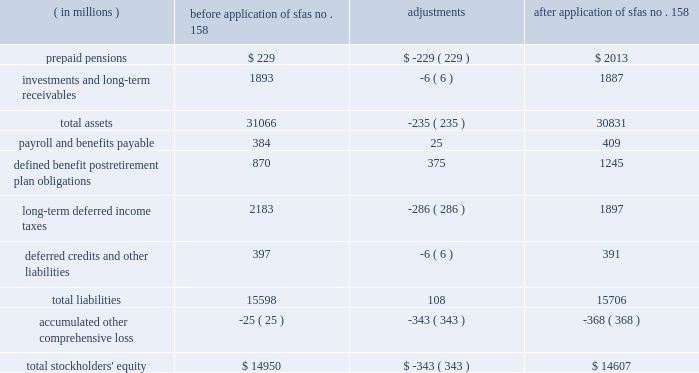The table illustrates the incremental effect of applying sfas no .
158 on individual line items of the balance sheet as of december 31 , 2006 .
Before after application of application of ( in millions ) sfas no .
158 adjustments sfas no .
158 .
Sab no .
108 2013 in september 2006 , the securities and exchange commission issued staff accounting bulletin ( 2018 2018sab 2019 2019 ) no .
108 , 2018 2018financial statements 2013 considering the effects of prior year misstatements when quantifying misstatements in current year financial statements . 2019 2019 sab no .
108 addresses how a registrant should quantify the effect of an error in the financial statements for purposes of assessing materiality and requires that the effect be computed using both the current year income statement perspective ( 2018 2018rollover 2019 2019 ) and the year end balance sheet perspective ( 2018 2018iron curtain 2019 2019 ) methods for fiscal years ending after november 15 , 2006 .
If a change in the method of quantifying errors is required under sab no .
108 , this represents a change in accounting policy ; therefore , if the use of both methods results in a larger , material misstatement than the previously applied method , the financial statements must be adjusted .
Sab no .
108 allows the cumulative effect of such adjustments to be made to opening retained earnings upon adoption .
Marathon adopted sab no .
108 for the year ended december 31 , 2006 , and adoption did not have an effect on marathon 2019s consolidated results of operations , financial position or cash flows .
Eitf issue no .
06-03 2013 in june 2006 , the fasb ratified the consensus reached by the eitf regarding issue no .
06-03 , 2018 2018how taxes collected from customers and remitted to governmental authorities should be presented in the income statement ( that is , gross versus net presentation ) . 2019 2019 included in the scope of this issue are any taxes assessed by a governmental authority that are imposed on and concurrent with a specific revenue-producing transaction between a seller and a customer .
The eitf concluded that the presentation of such taxes on a gross basis ( included in revenues and costs ) or a net basis ( excluded from revenues ) is an accounting policy decision that should be disclosed pursuant to accounting principles board ( 2018 2018apb 2019 2019 ) opinion no .
22 , 2018 2018disclosure of accounting policies . 2019 2019 in addition , the amounts of such taxes reported on a gross basis must be disclosed if those tax amounts are significant .
The policy disclosures required by this consensus are included in note 1 under the heading 2018 2018consumer excise taxes 2019 2019 and the taxes reported on a gross basis are presented separately as consumer excise taxes in the consolidated statements of income .
Eitf issue no .
04-13 2013 in september 2005 , the fasb ratified the consensus reached by the eitf on issue no .
04-13 , 2018 2018accounting for purchases and sales of inventory with the same counterparty . 2019 2019 the consensus establishes the circumstances under which two or more inventory purchase and sale transactions with the same counterparty should be recognized at fair value or viewed as a single exchange transaction subject to apb opinion no .
29 , 2018 2018accounting for nonmonetary transactions . 2019 2019 in general , two or more transactions with the same counterparty must be combined for purposes of applying apb opinion no .
29 if they are entered into in contemplation of each other .
The purchase and sale transactions may be pursuant to a single contractual arrangement or separate contractual arrangements and the inventory purchased or sold may be in the form of raw materials , work-in-process or finished goods .
Effective april 1 , 2006 , marathon adopted the provisions of eitf issue no .
04-13 prospectively .
Eitf issue no .
04-13 changes the accounting for matching buy/sell arrangements that are entered into or modified on or after april 1 , 2006 ( except for those accounted for as derivative instruments , which are discussed below ) .
In a typical matching buy/sell transaction , marathon enters into a contract to sell a particular quantity and quality of crude oil or refined product at a specified location and date to a particular counterparty and simultaneously agrees to buy a particular quantity and quality of the same commodity at a specified location on the same or another specified date from the same counterparty .
Prior to adoption of eitf issue no .
04-13 , marathon recorded such matching buy/sell transactions in both revenues and cost of revenues as separate sale and purchase transactions .
Upon adoption , these transactions are accounted for as exchanges of inventory .
The scope of eitf issue no .
04-13 excludes matching buy/sell arrangements that are accounted for as derivative instruments .
A portion of marathon 2019s matching buy/sell transactions are 2018 2018nontraditional derivative instruments , 2019 2019 which are discussed in note 1 .
Although the accounting for nontraditional derivative instruments is outside the scope of eitf issue no .
04-13 , the conclusions reached in that consensus caused marathon to reconsider the guidance in eitf issue no .
03-11 , 2018 2018reporting realized gains and losses on derivative instruments that are subject to fasb statement no .
133 and not 2018 2018held for trading purposes 2019 2019 as defined in issue no .
02-3 . 2019 2019 as a result , effective for contracts entered into or modified on or after april 1 , 2006 , the effects of matching buy/sell arrangements accounted for as nontraditional derivative instruments are recognized on a net basis in net income and are classified as cost of revenues .
Prior to this change , marathon recorded these transactions in both revenues and cost of revenues as separate sale and purchase transactions .
This change in accounting principle is being applied on a prospective basis because it is impracticable to apply the change on a retrospective basis. .
What was the percentage change in total assets due to the adoption of fas 158? 
Computations: (-235 / 31066)
Answer: -0.00756. 